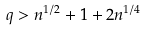Convert formula to latex. <formula><loc_0><loc_0><loc_500><loc_500>q > n ^ { 1 / 2 } + 1 + 2 n ^ { 1 / 4 }</formula> 